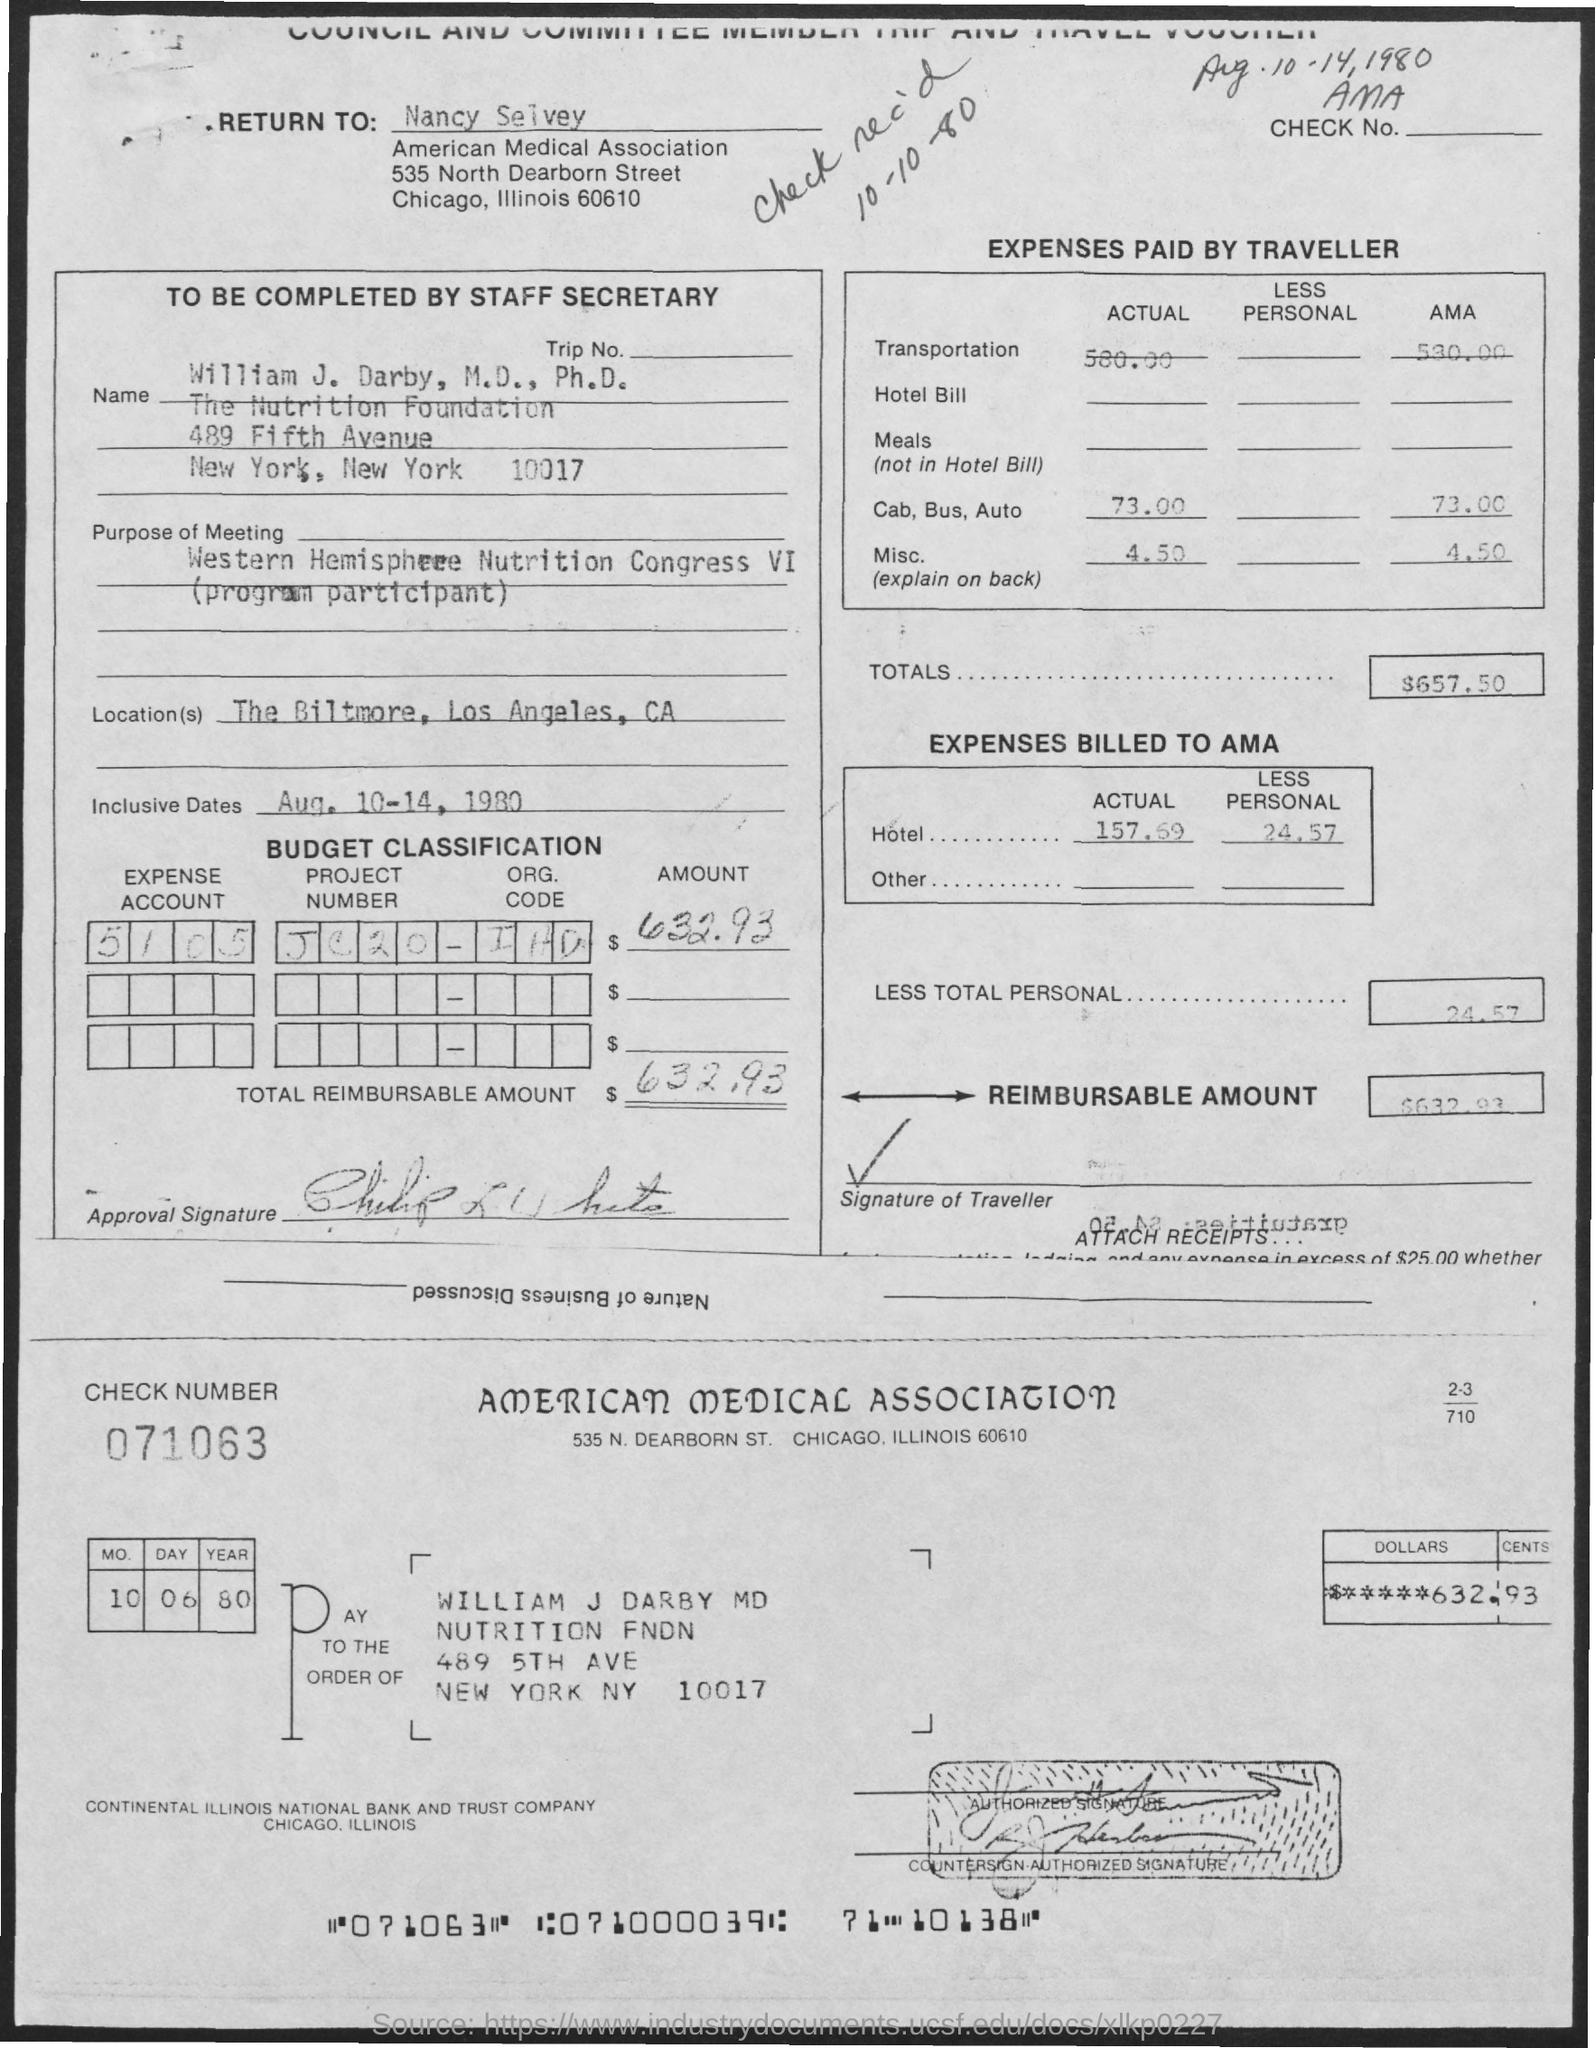List a handful of essential elements in this visual. The expense account is 5105. Please provide the project number JC20... Please provide the check number, which is 071063... The reimbursable amount is $632.93. The total amount is $657.50. 